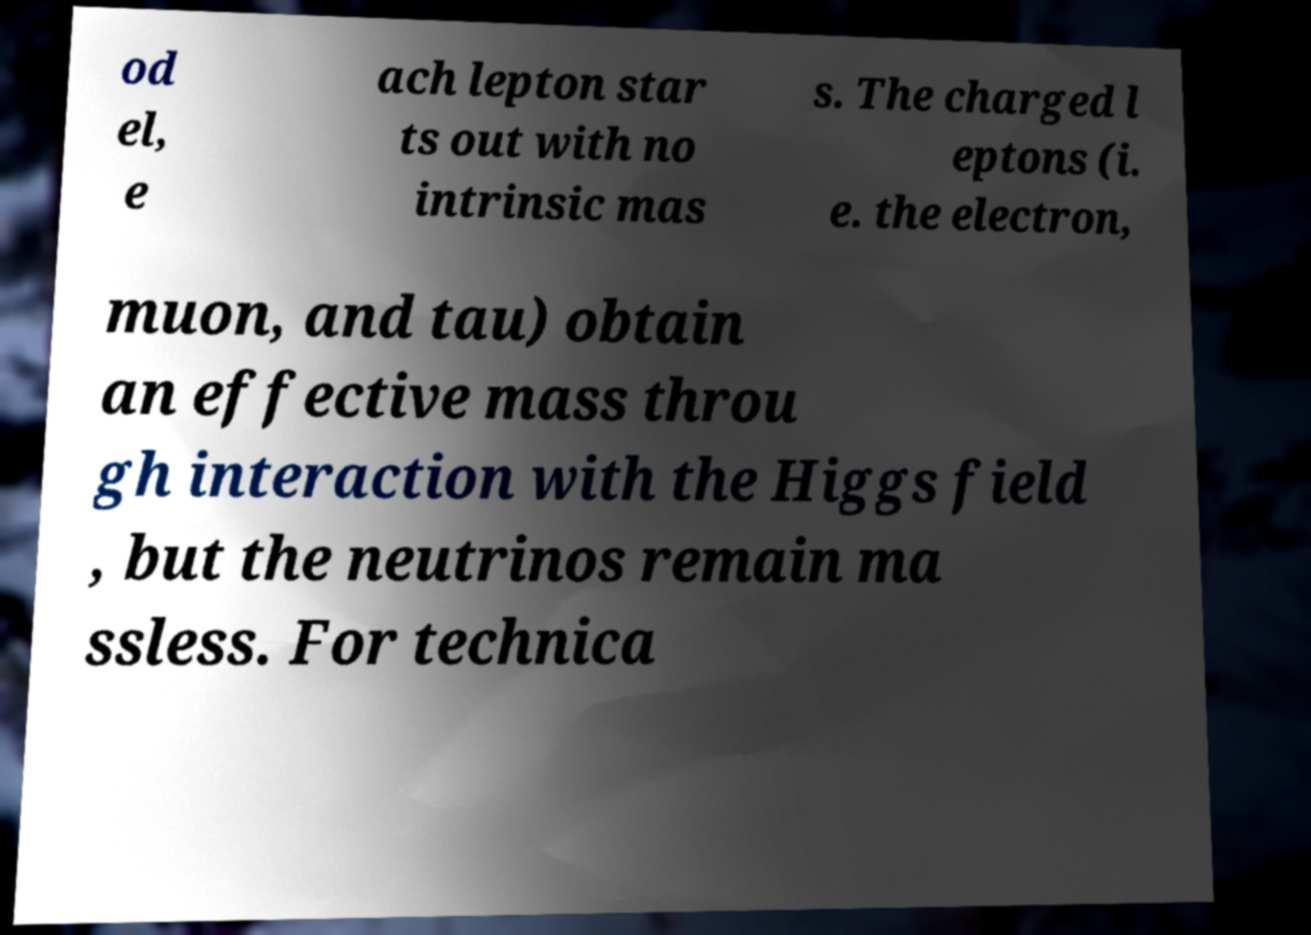Please identify and transcribe the text found in this image. od el, e ach lepton star ts out with no intrinsic mas s. The charged l eptons (i. e. the electron, muon, and tau) obtain an effective mass throu gh interaction with the Higgs field , but the neutrinos remain ma ssless. For technica 